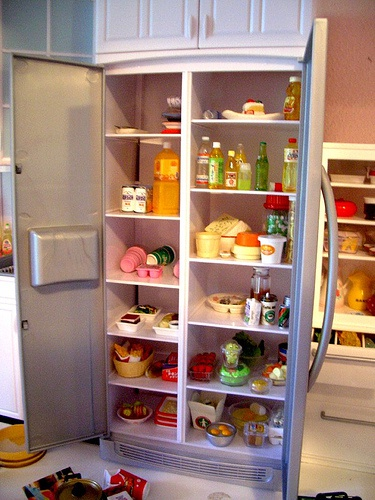Describe the objects in this image and their specific colors. I can see refrigerator in gray, tan, and darkgray tones, bottle in gray, orange, red, and gold tones, bowl in gray, red, and maroon tones, bottle in gray, tan, and olive tones, and cup in gray, maroon, and brown tones in this image. 